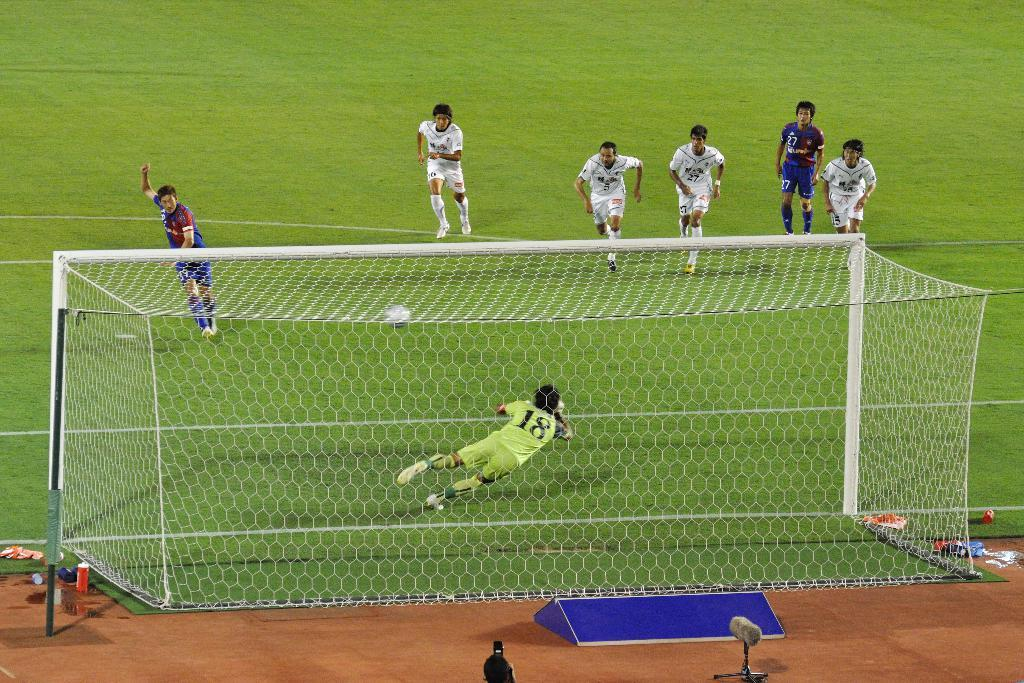<image>
Present a compact description of the photo's key features. a group of soccer players with the goalie 18 attempting to block a shot 